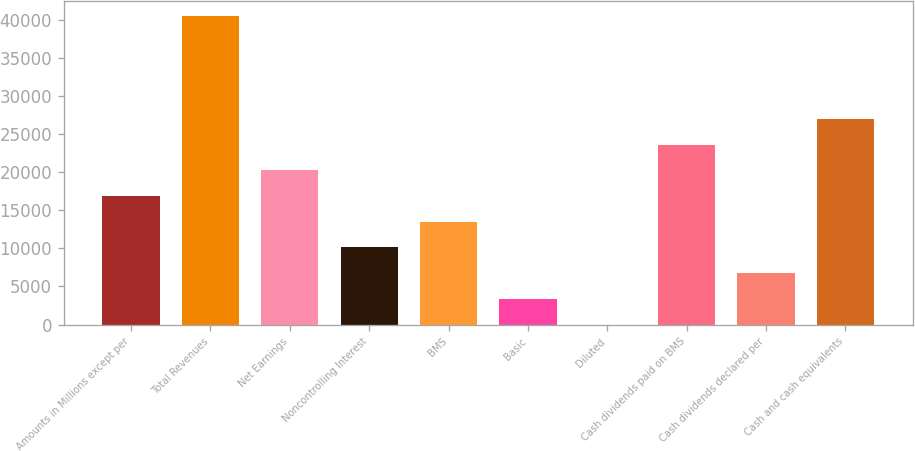Convert chart. <chart><loc_0><loc_0><loc_500><loc_500><bar_chart><fcel>Amounts in Millions except per<fcel>Total Revenues<fcel>Net Earnings<fcel>Noncontrolling Interest<fcel>BMS<fcel>Basic<fcel>Diluted<fcel>Cash dividends paid on BMS<fcel>Cash dividends declared per<fcel>Cash and cash equivalents<nl><fcel>16875.1<fcel>40498.6<fcel>20249.9<fcel>10125.5<fcel>13500.3<fcel>3375.98<fcel>1.2<fcel>23624.7<fcel>6750.76<fcel>26999.4<nl></chart> 